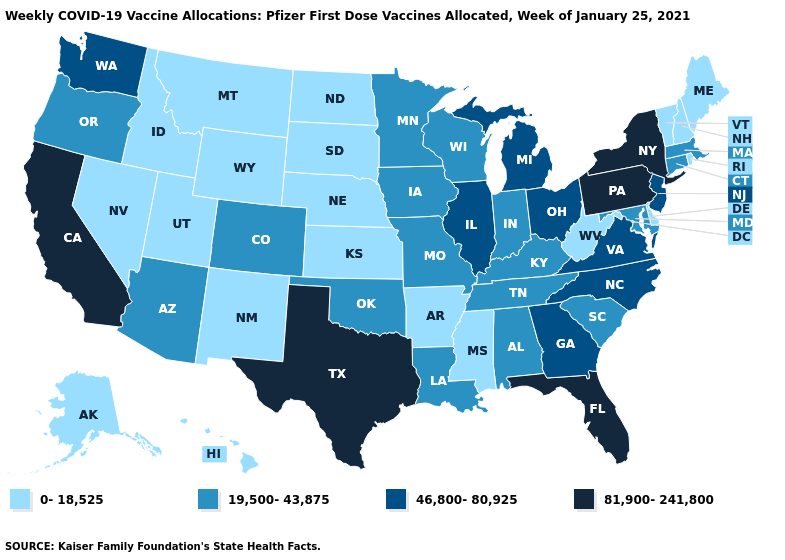Does the map have missing data?
Answer briefly. No. What is the highest value in the Northeast ?
Quick response, please. 81,900-241,800. Which states have the highest value in the USA?
Write a very short answer. California, Florida, New York, Pennsylvania, Texas. Does West Virginia have the lowest value in the USA?
Write a very short answer. Yes. What is the value of New Hampshire?
Concise answer only. 0-18,525. Does Idaho have the lowest value in the West?
Write a very short answer. Yes. Among the states that border Massachusetts , does New York have the highest value?
Give a very brief answer. Yes. Name the states that have a value in the range 46,800-80,925?
Short answer required. Georgia, Illinois, Michigan, New Jersey, North Carolina, Ohio, Virginia, Washington. Name the states that have a value in the range 46,800-80,925?
Be succinct. Georgia, Illinois, Michigan, New Jersey, North Carolina, Ohio, Virginia, Washington. Name the states that have a value in the range 19,500-43,875?
Quick response, please. Alabama, Arizona, Colorado, Connecticut, Indiana, Iowa, Kentucky, Louisiana, Maryland, Massachusetts, Minnesota, Missouri, Oklahoma, Oregon, South Carolina, Tennessee, Wisconsin. Which states have the lowest value in the Northeast?
Concise answer only. Maine, New Hampshire, Rhode Island, Vermont. Name the states that have a value in the range 19,500-43,875?
Answer briefly. Alabama, Arizona, Colorado, Connecticut, Indiana, Iowa, Kentucky, Louisiana, Maryland, Massachusetts, Minnesota, Missouri, Oklahoma, Oregon, South Carolina, Tennessee, Wisconsin. Which states have the lowest value in the MidWest?
Keep it brief. Kansas, Nebraska, North Dakota, South Dakota. What is the value of California?
Short answer required. 81,900-241,800. What is the highest value in the USA?
Write a very short answer. 81,900-241,800. 